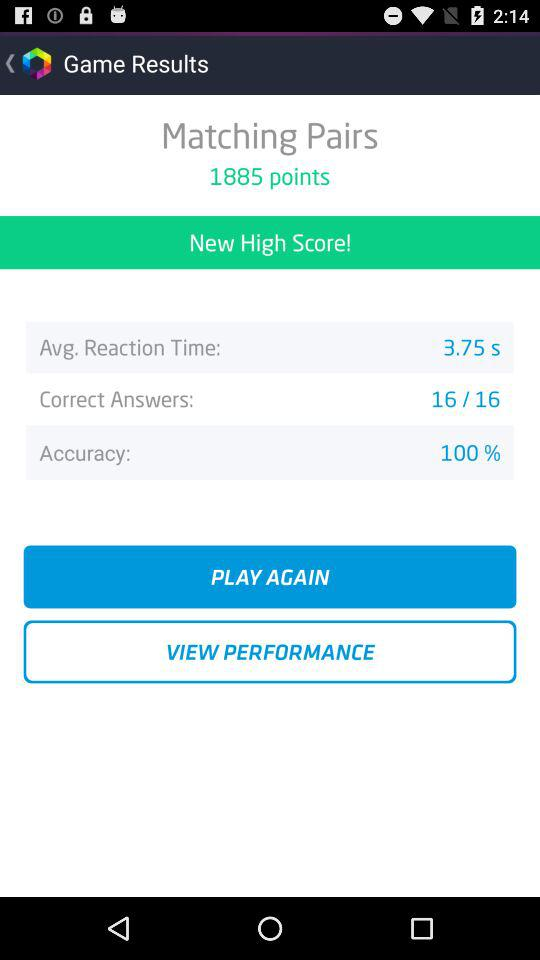How many points are there? There are 1885 points. 